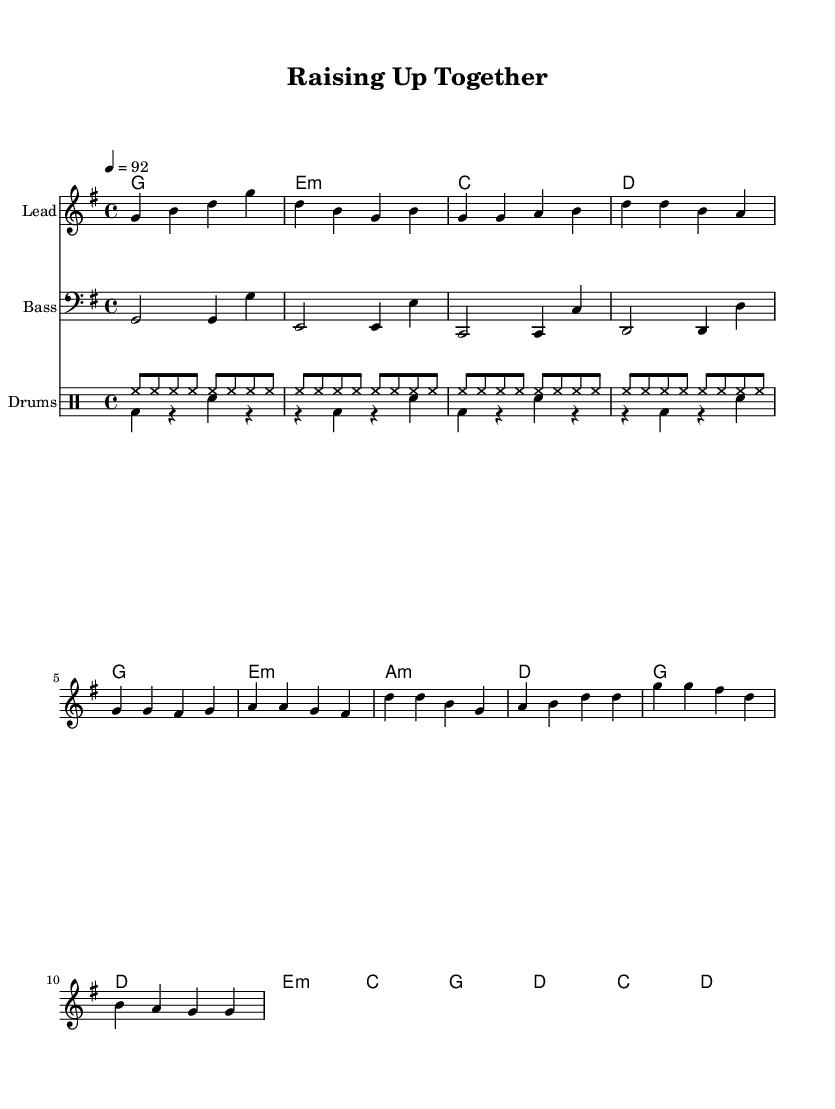What is the key signature of this music? The key signature is G major, which has one sharp (F#). This is indicated at the beginning of the staff.
Answer: G major What is the time signature of this music? The time signature is 4/4, which denotes that there are four beats in each measure and the quarter note receives one beat. This is also indicated at the beginning of the sheet music.
Answer: 4/4 What is the tempo marking for this piece? The tempo marking is 92 beats per minute, meaning the music should be played at a moderate pace. This is specified at the start with "4 = 92."
Answer: 92 How many measures are there in the lead synth section? The lead synth section consists of 16 measures. By counting the distinct musical phrases and bars in the lead synth notation, one can account for the total measures.
Answer: 16 What is the form of this hip hop anthem? The form includes an intro, verse, and chorus sections. This structure is common in hip hop music, allowing for lyrical variation and thematic development.
Answer: Intro, Verse, Chorus What is the rhythmic style of the drum part? The rhythmic style is consistent with a four-to-the-floor beat, typical in hip hop, where the kick drum is emphasized on every beat, and the hi-hats create an energetic groove. This estilo is indicated in the drum notation.
Answer: Four-to-the-floor What is the emotional theme conveyed through the lyrics of this hip hop anthem based on its structure? The emotional theme celebrates joy and community service, reflecting the role of parenthood and helping others, as inferred from the title "Raising Up Together." The securely uplifting tone connects with the vibrant, energetic style of hip hop.
Answer: Joy and community service 